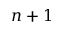<formula> <loc_0><loc_0><loc_500><loc_500>n + 1</formula> 